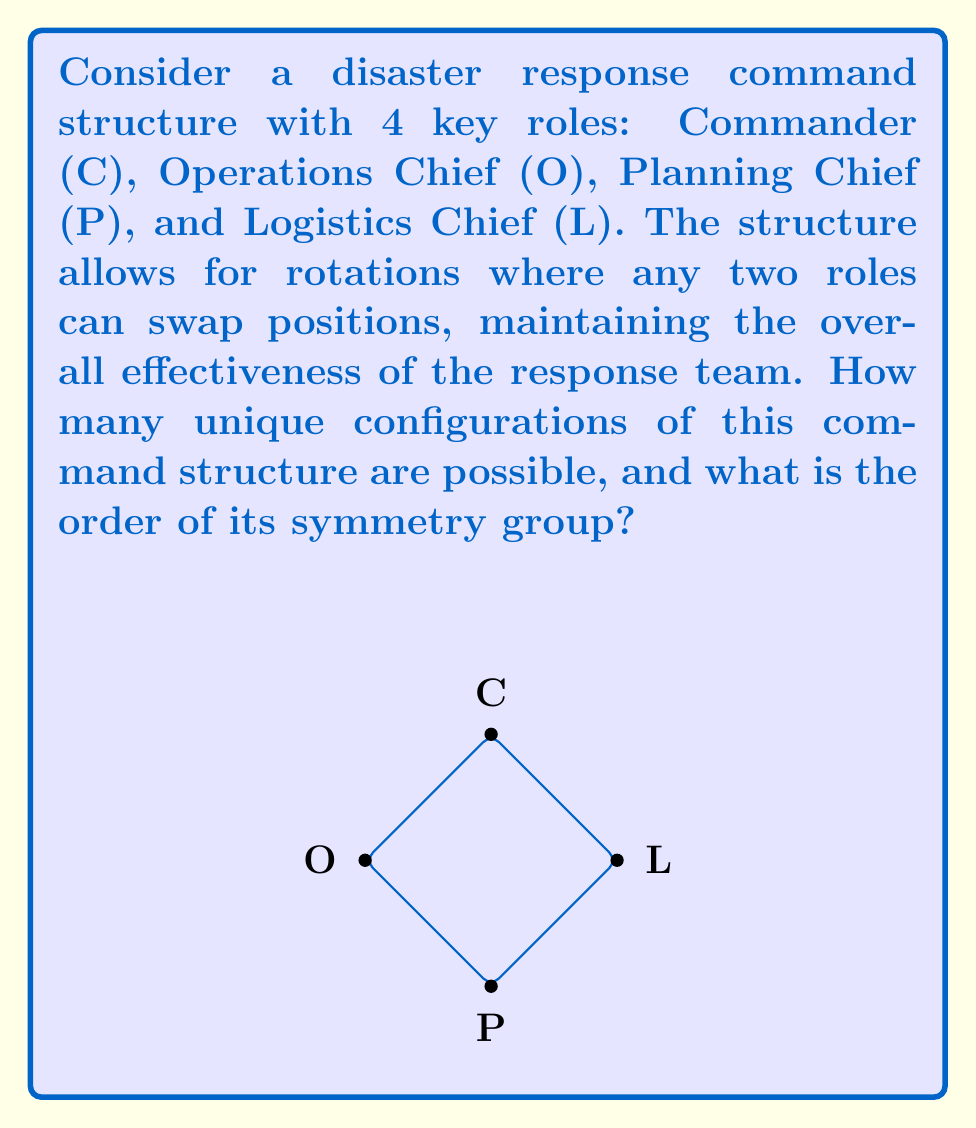Show me your answer to this math problem. Let's approach this step-by-step:

1) First, we need to understand what symmetries are possible in this structure. The question states that any two roles can swap positions, which means we're dealing with permutations of 4 elements.

2) The symmetry group of this structure is isomorphic to the symmetric group $S_4$, which consists of all permutations of 4 elements.

3) To find the order of $S_4$, we use the factorial function:

   $|S_4| = 4! = 4 \times 3 \times 2 \times 1 = 24$

4) This means there are 24 different ways to arrange the 4 roles.

5) We can verify this by listing out the possible permutations:
   - Identity permutation: (C)(O)(P)(L)
   - 6 permutations swapping 2 elements: (CO)(P)(L), (CP)(O)(L), (CL)(O)(P), (OP)(C)(L), (OL)(C)(P), (PL)(C)(O)
   - 8 permutations cycling 3 elements: (COP)(L), (CPO)(L), (COL)(P), (CLO)(P), (CPL)(O), (CLP)(O), (OPL)(C), (OLP)(C)
   - 6 permutations swapping 2 pairs: (CO)(PL), (CP)(OL), (CL)(OP)
   - 3 permutations cycling all 4 elements: (COPL), (COLP), (CPOL)

6) Each of these permutations represents a unique configuration of the command structure, and together they form the symmetry group of the structure.

Therefore, there are 24 unique configurations possible, and the order of the symmetry group is also 24.
Answer: 24 